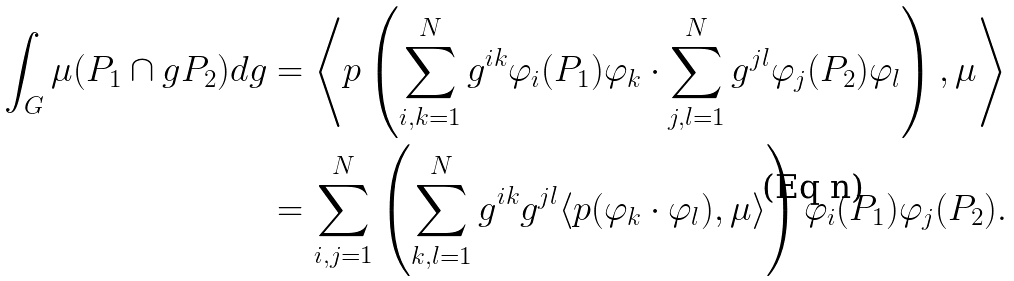Convert formula to latex. <formula><loc_0><loc_0><loc_500><loc_500>\int _ { G } \mu ( P _ { 1 } \cap g P _ { 2 } ) d g & = \left \langle p \left ( \sum _ { i , k = 1 } ^ { N } g ^ { i k } \varphi _ { i } ( P _ { 1 } ) \varphi _ { k } \cdot \sum _ { j , l = 1 } ^ { N } g ^ { j l } \varphi _ { j } ( P _ { 2 } ) \varphi _ { l } \right ) , \mu \right \rangle \\ & = \sum _ { i , j = 1 } ^ { N } \left ( \sum _ { k , l = 1 } ^ { N } g ^ { i k } g ^ { j l } \langle p ( \varphi _ { k } \cdot \varphi _ { l } ) , \mu \rangle \right ) \varphi _ { i } ( P _ { 1 } ) \varphi _ { j } ( P _ { 2 } ) .</formula> 